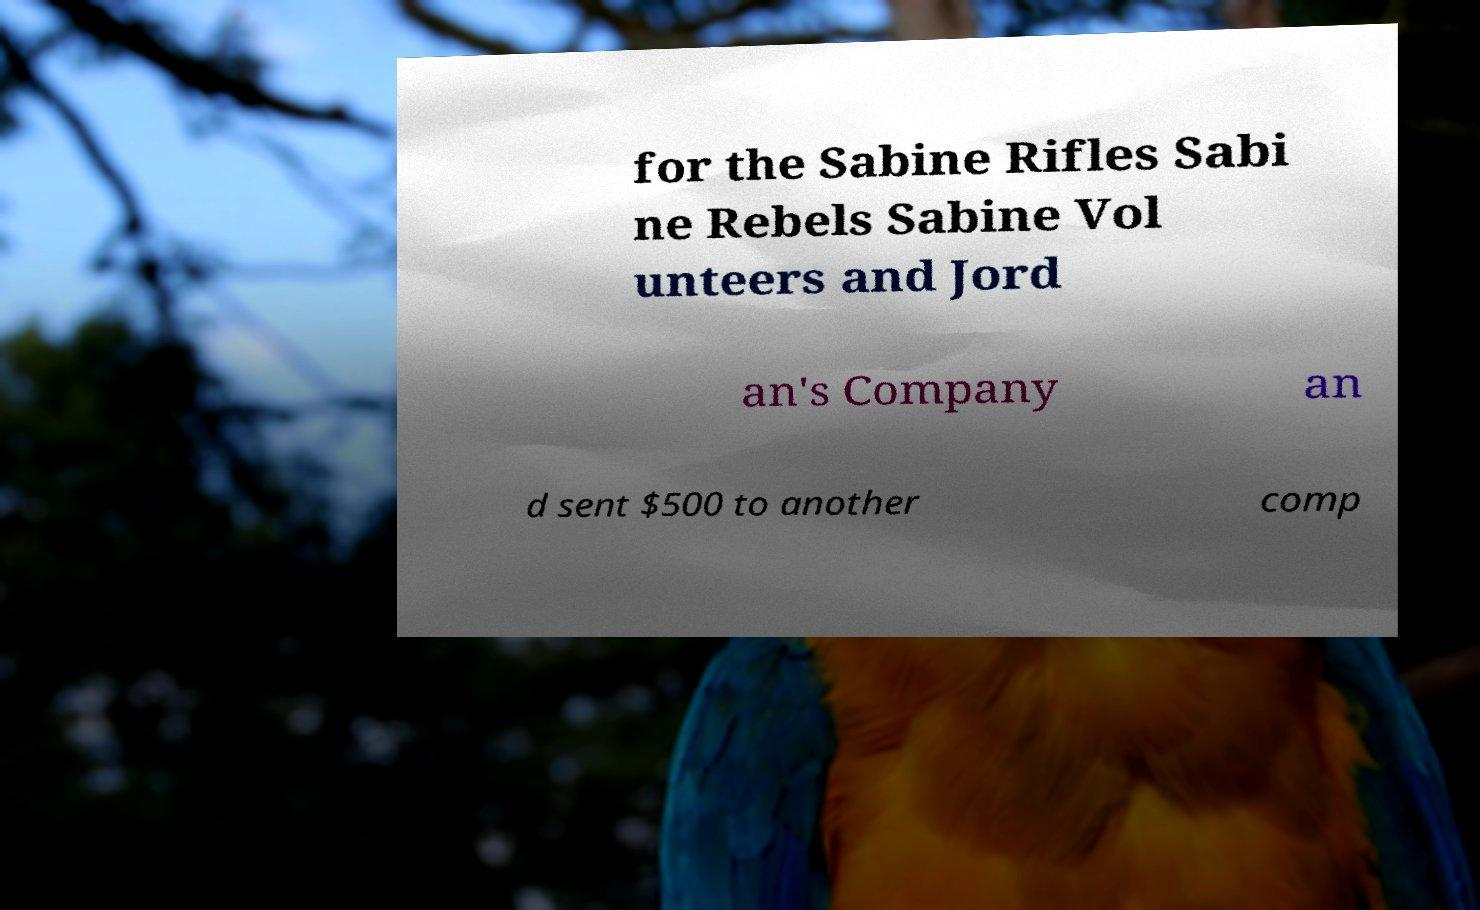Could you assist in decoding the text presented in this image and type it out clearly? for the Sabine Rifles Sabi ne Rebels Sabine Vol unteers and Jord an's Company an d sent $500 to another comp 